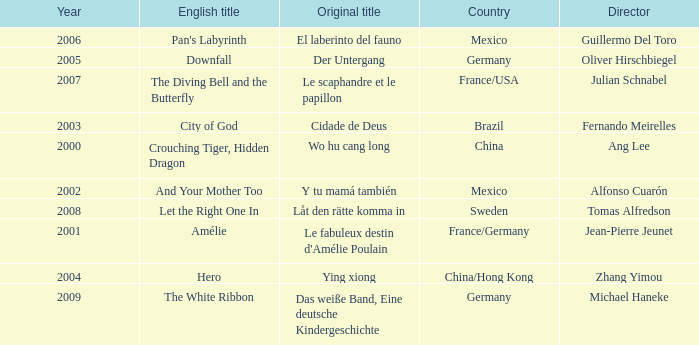Name the title of jean-pierre jeunet Amélie. 